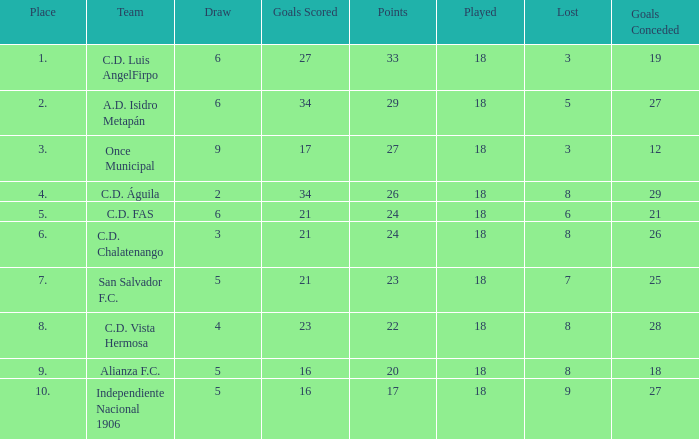What are the number of goals conceded that has a played greater than 18? 0.0. Help me parse the entirety of this table. {'header': ['Place', 'Team', 'Draw', 'Goals Scored', 'Points', 'Played', 'Lost', 'Goals Conceded'], 'rows': [['1.', 'C.D. Luis AngelFirpo', '6', '27', '33', '18', '3', '19'], ['2.', 'A.D. Isidro Metapán', '6', '34', '29', '18', '5', '27'], ['3.', 'Once Municipal', '9', '17', '27', '18', '3', '12'], ['4.', 'C.D. Águila', '2', '34', '26', '18', '8', '29'], ['5.', 'C.D. FAS', '6', '21', '24', '18', '6', '21'], ['6.', 'C.D. Chalatenango', '3', '21', '24', '18', '8', '26'], ['7.', 'San Salvador F.C.', '5', '21', '23', '18', '7', '25'], ['8.', 'C.D. Vista Hermosa', '4', '23', '22', '18', '8', '28'], ['9.', 'Alianza F.C.', '5', '16', '20', '18', '8', '18'], ['10.', 'Independiente Nacional 1906', '5', '16', '17', '18', '9', '27']]} 